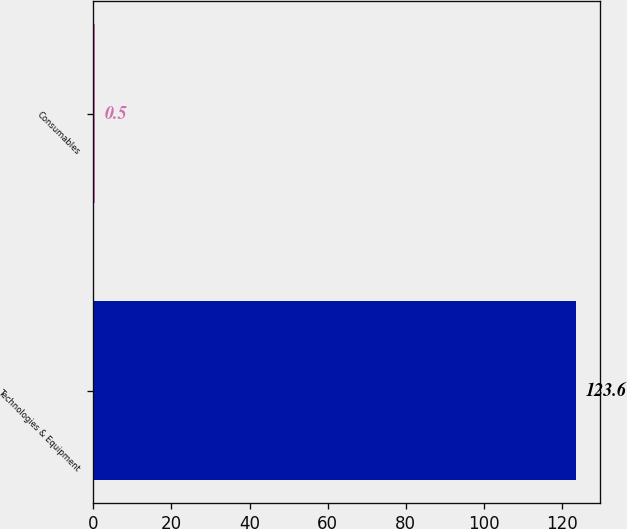<chart> <loc_0><loc_0><loc_500><loc_500><bar_chart><fcel>Technologies & Equipment<fcel>Consumables<nl><fcel>123.6<fcel>0.5<nl></chart> 